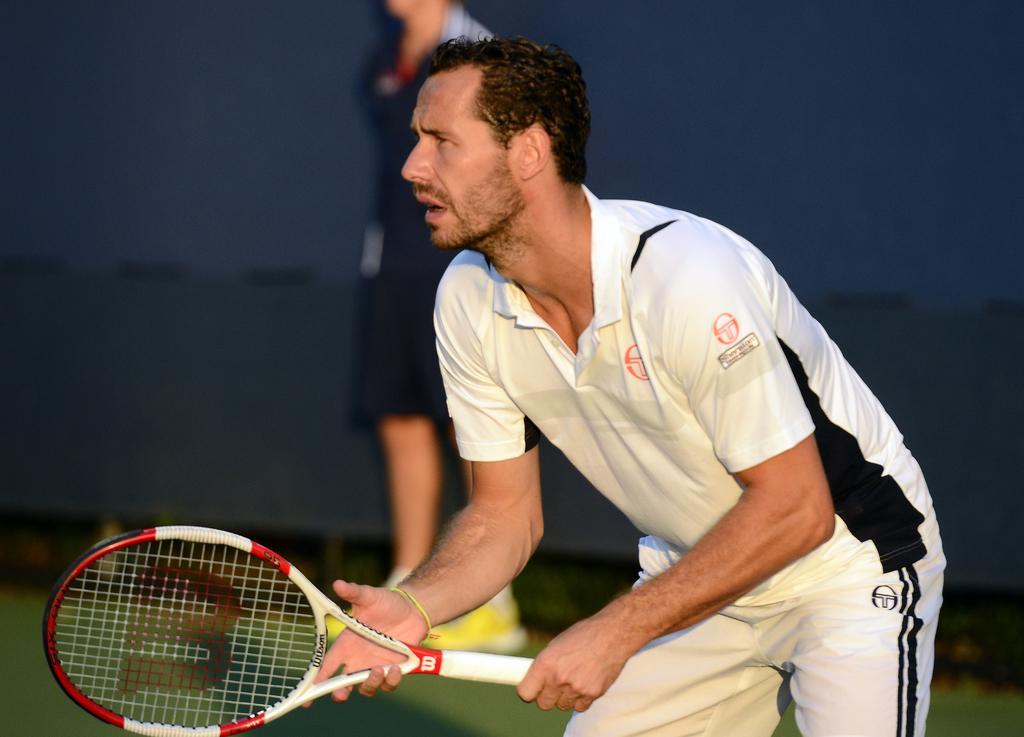Describe this image in one or two sentences. In this picture there is a person in white dress holding a tennis racket. The background is blurred. 